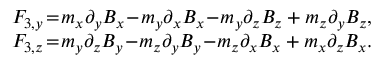<formula> <loc_0><loc_0><loc_500><loc_500>\begin{array} { r } { F _ { 3 , y } \, = \, m _ { x } \partial _ { y } B _ { x } \, - \, m _ { y } \partial _ { x } B _ { x } \, - \, m _ { y } \partial _ { z } B _ { z } + m _ { z } \partial _ { y } B _ { z } , } \\ { F _ { 3 , z } \, = \, m _ { y } \partial _ { z } B _ { y } \, - \, m _ { z } \partial _ { y } B _ { y } \, - \, m _ { z } \partial _ { x } B _ { x } + m _ { x } \partial _ { z } B _ { x } . } \end{array}</formula> 